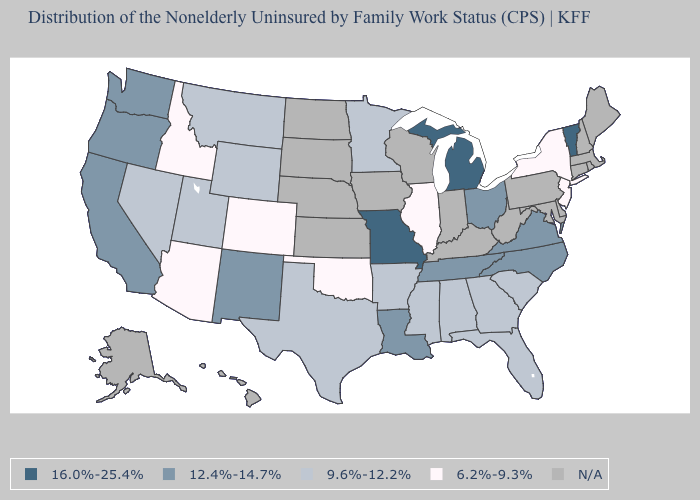Does Texas have the highest value in the USA?
Quick response, please. No. What is the value of Colorado?
Quick response, please. 6.2%-9.3%. What is the value of Virginia?
Be succinct. 12.4%-14.7%. Name the states that have a value in the range 6.2%-9.3%?
Give a very brief answer. Arizona, Colorado, Idaho, Illinois, New Jersey, New York, Oklahoma. Name the states that have a value in the range 16.0%-25.4%?
Concise answer only. Michigan, Missouri, Vermont. What is the value of California?
Be succinct. 12.4%-14.7%. How many symbols are there in the legend?
Keep it brief. 5. Which states have the lowest value in the Northeast?
Write a very short answer. New Jersey, New York. What is the value of Kansas?
Answer briefly. N/A. What is the value of Arizona?
Short answer required. 6.2%-9.3%. Among the states that border Georgia , which have the lowest value?
Write a very short answer. Alabama, Florida, South Carolina. What is the lowest value in states that border Pennsylvania?
Concise answer only. 6.2%-9.3%. What is the lowest value in the Northeast?
Be succinct. 6.2%-9.3%. What is the value of Massachusetts?
Give a very brief answer. N/A. 